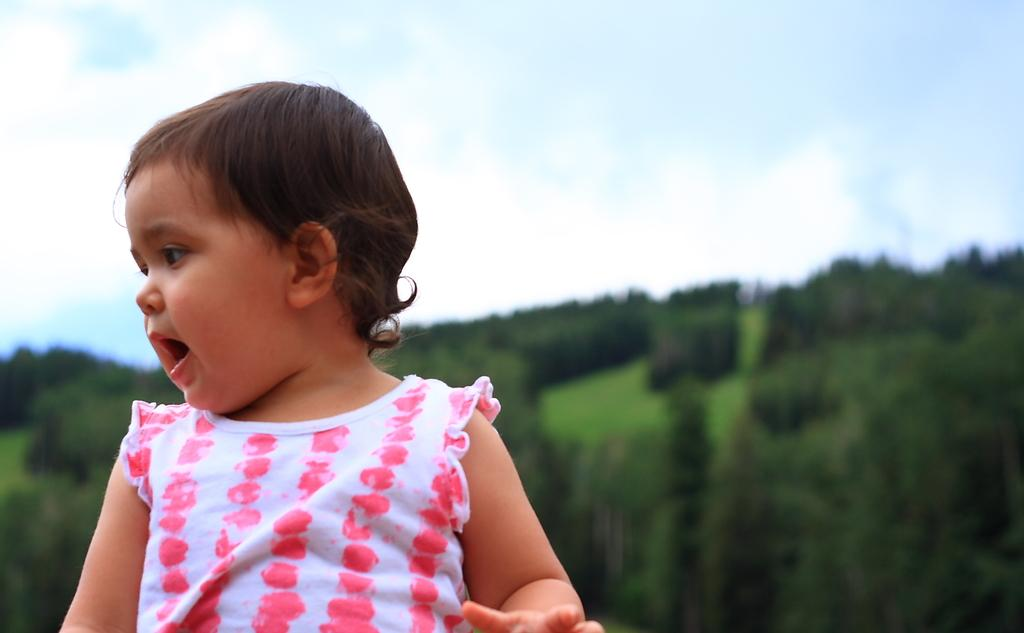What is the main subject of the image? There is a child in the image. What can be seen in the background of the image? The background of the image is green. What part of the natural environment is visible in the image? The sky is visible in the image. What type of structure can be seen supporting the yoke in the image? There is no structure or yoke present in the image; it features a child with a green background and visible sky. 